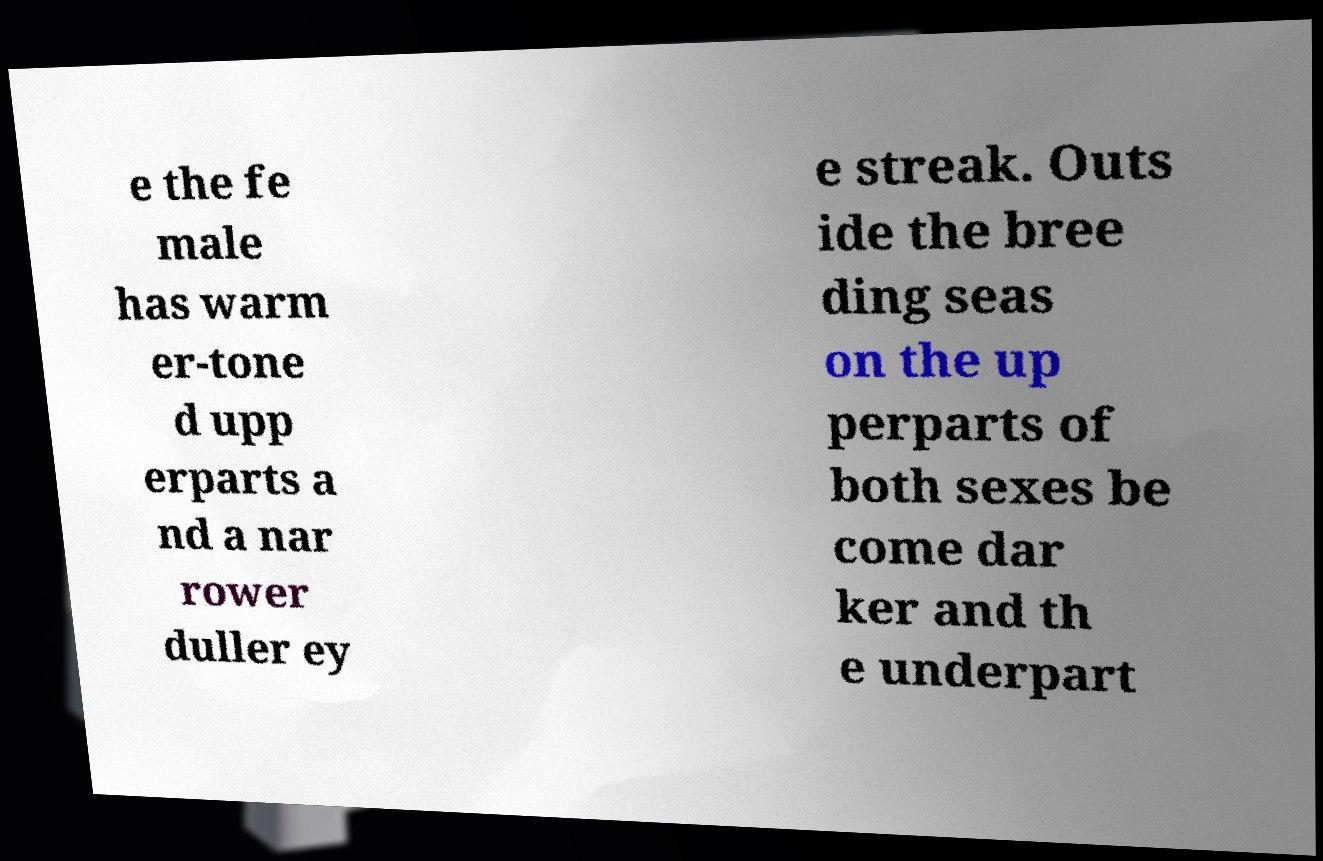Please identify and transcribe the text found in this image. e the fe male has warm er-tone d upp erparts a nd a nar rower duller ey e streak. Outs ide the bree ding seas on the up perparts of both sexes be come dar ker and th e underpart 